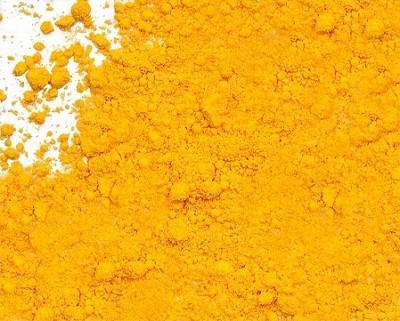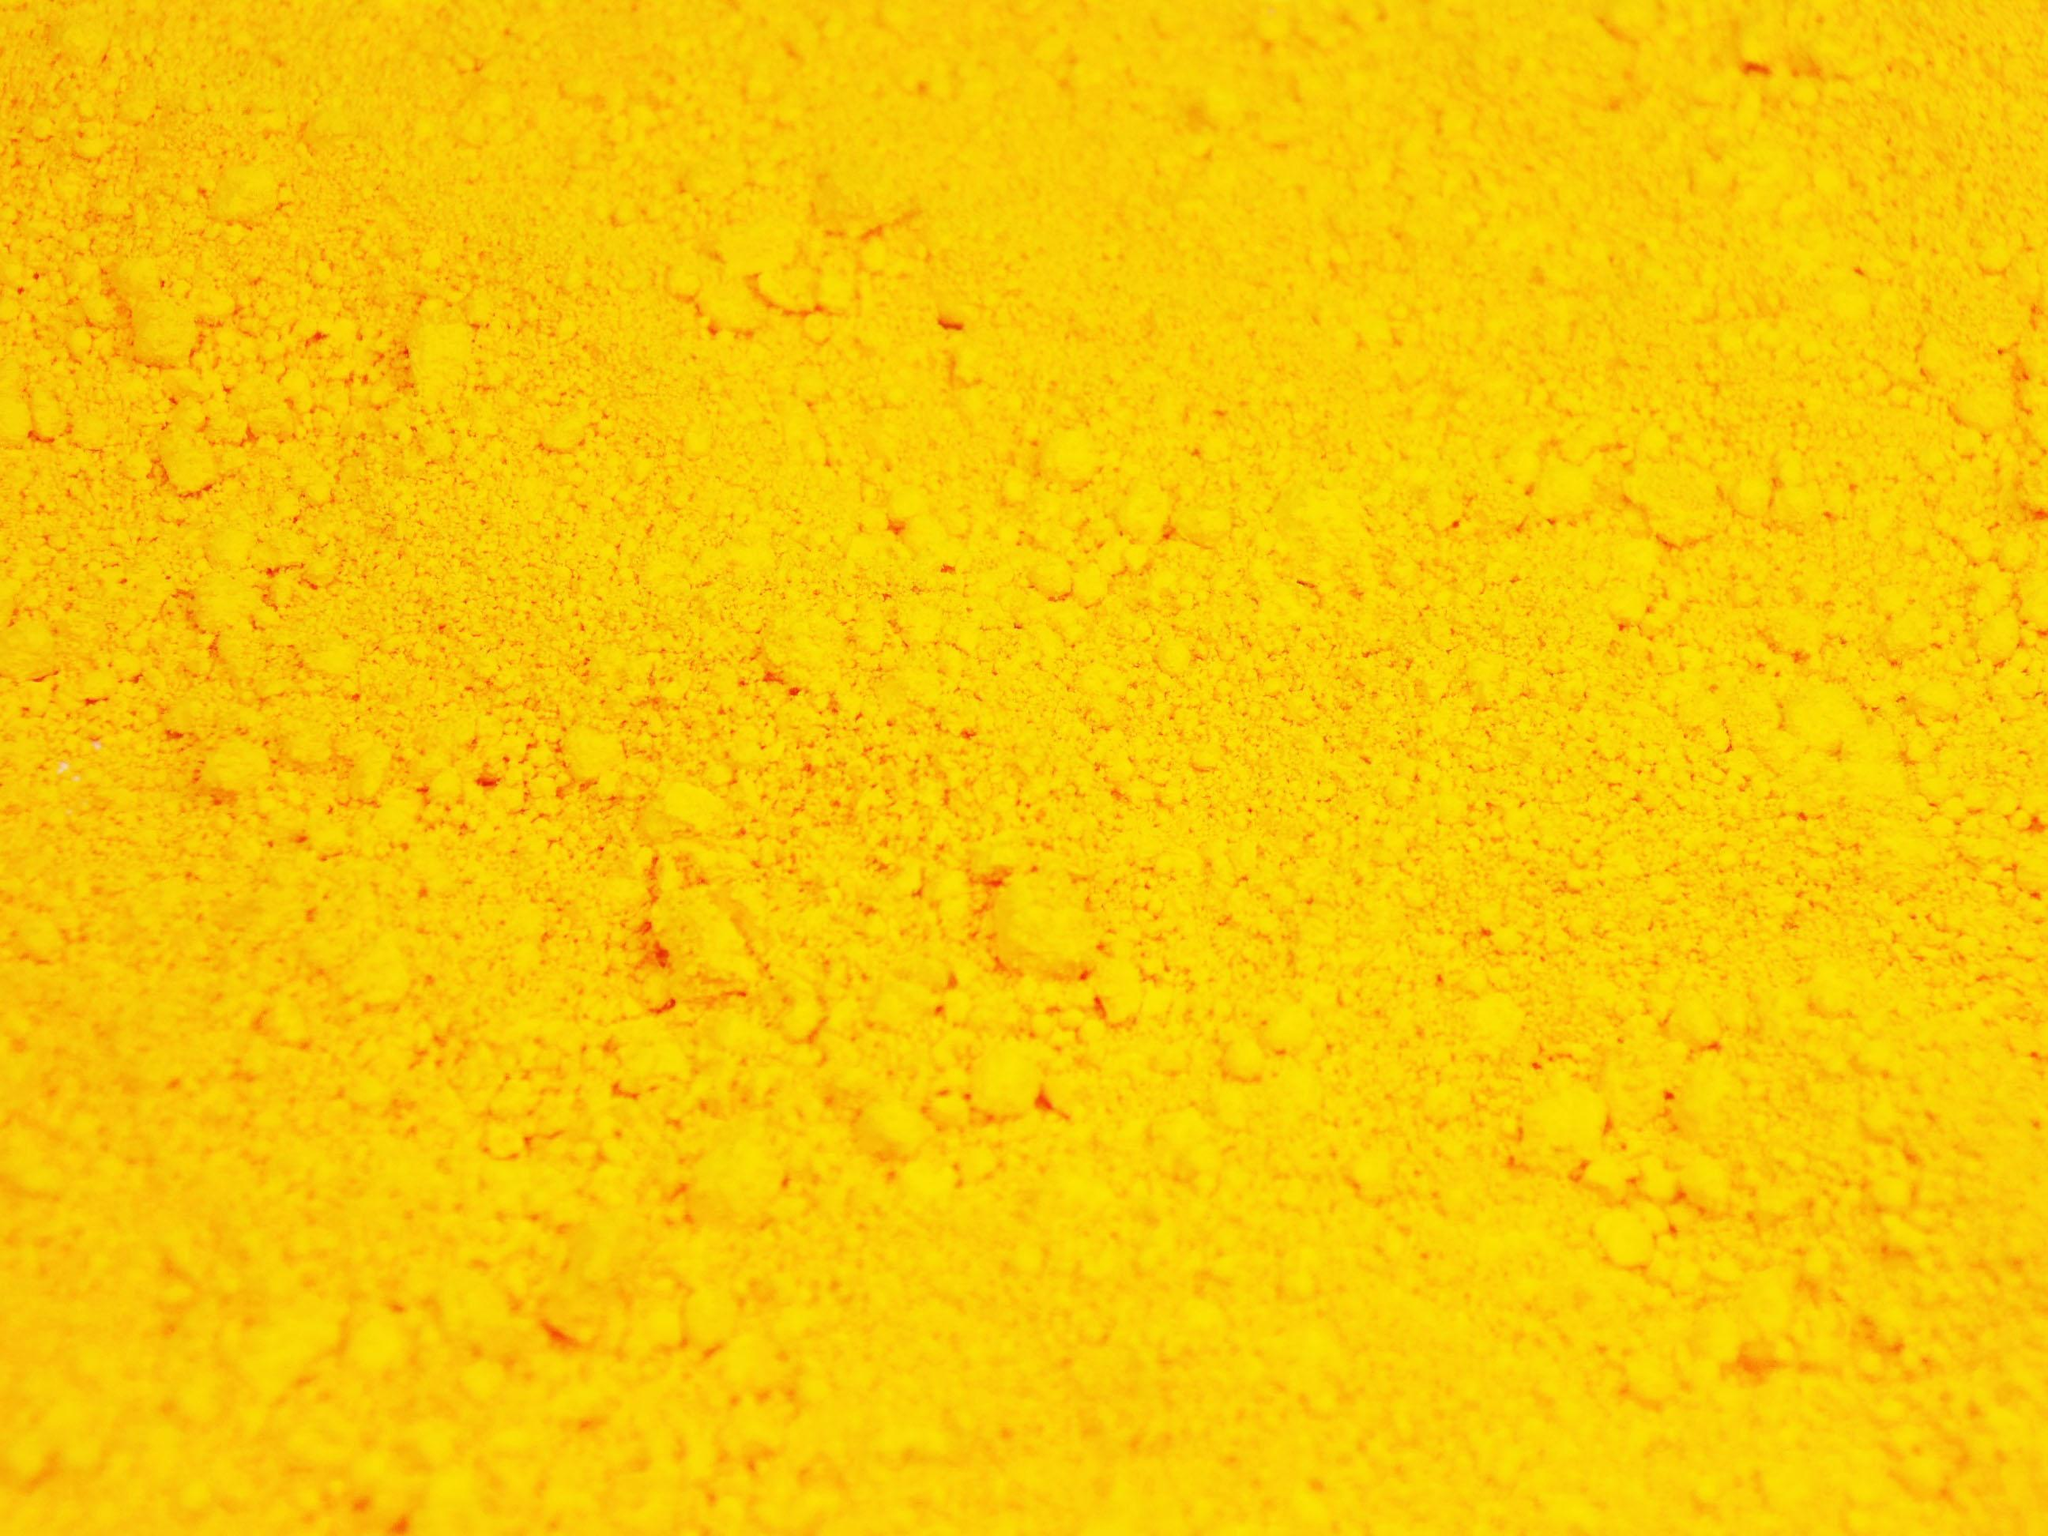The first image is the image on the left, the second image is the image on the right. Analyze the images presented: Is the assertion "An image shows a mostly round pile of golden-yellow powder." valid? Answer yes or no. No. 